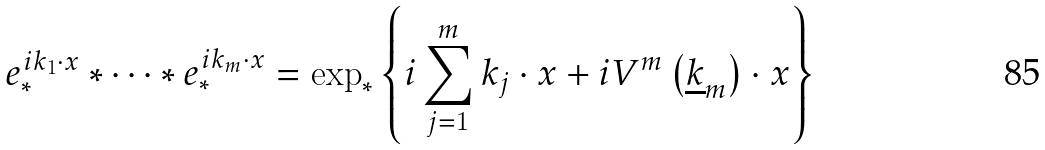<formula> <loc_0><loc_0><loc_500><loc_500>e _ { * } ^ { i k _ { 1 } \cdot x } * \cdots * e _ { * } ^ { i k _ { m } \cdot x } = \exp _ { * } \left \{ i \sum _ { j = 1 } ^ { m } k _ { j } \cdot x + i V ^ { m } \left ( \underline { k } _ { m } \right ) \cdot x \right \}</formula> 